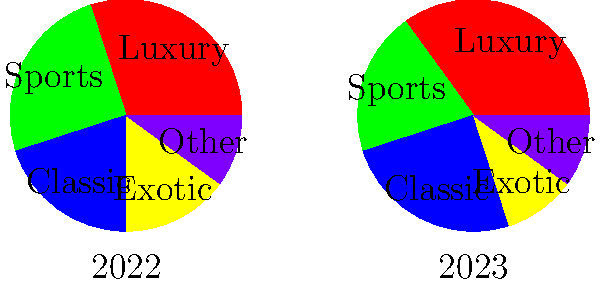Analyze the pie charts showing the distribution of funds raised from different car categories at charity events in 2022 and 2023. What is the total percentage increase in funds raised from Luxury and Sports cars combined from 2022 to 2023? To solve this problem, we need to follow these steps:

1. Identify the percentages for Luxury and Sports cars in 2022:
   Luxury (2022): 30%
   Sports (2022): 25%
   Combined (2022): 30% + 25% = 55%

2. Identify the percentages for Luxury and Sports cars in 2023:
   Luxury (2023): 35%
   Sports (2023): 20%
   Combined (2023): 35% + 20% = 55%

3. Calculate the difference between 2023 and 2022:
   Difference = 55% - 55% = 0%

Therefore, there was no increase in the combined percentage of funds raised from Luxury and Sports cars from 2022 to 2023. The total percentage remained the same at 55%.

To express this as a percentage increase:
Percentage increase = $\frac{\text{Increase}}{\text{Original}} \times 100\%$
                    = $\frac{0}{55} \times 100\%$
                    = 0%
Answer: 0% 